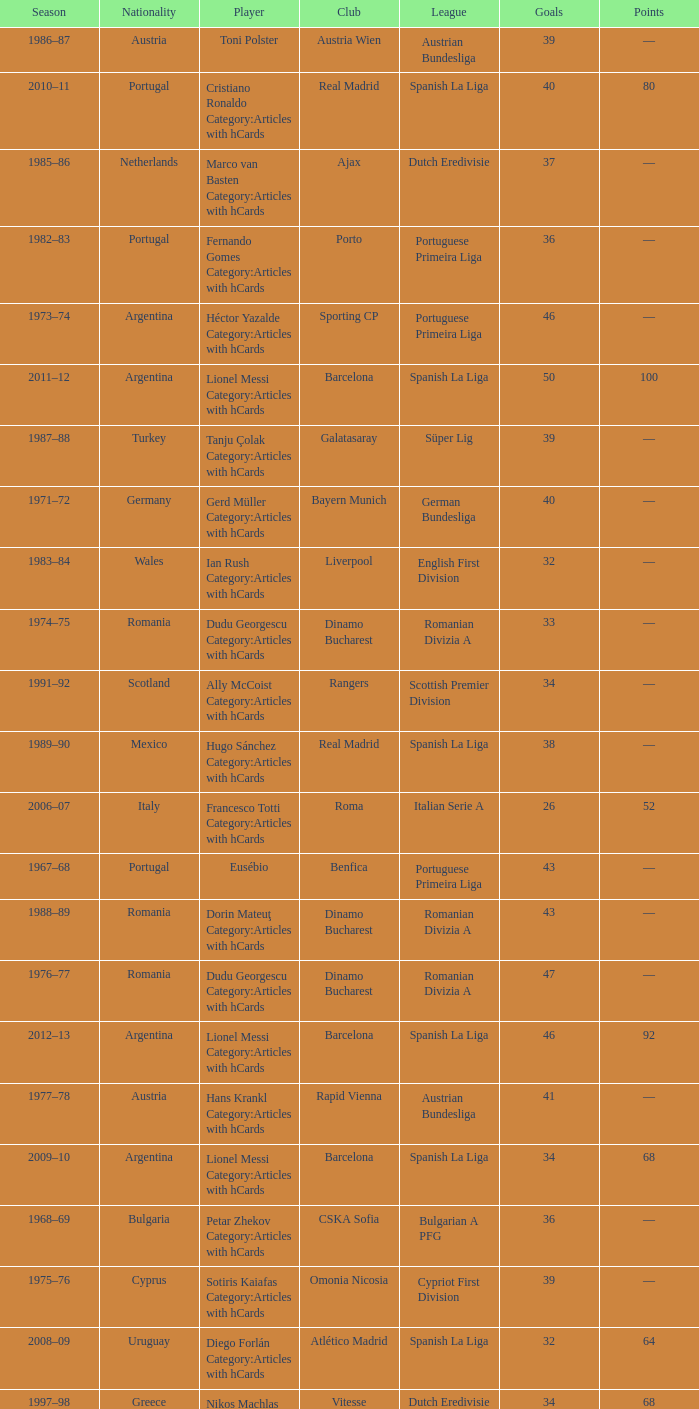Which league's nationality was Italy when there were 62 points? Italian Serie A. 